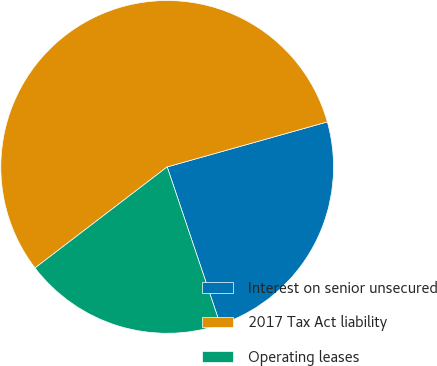Convert chart. <chart><loc_0><loc_0><loc_500><loc_500><pie_chart><fcel>Interest on senior unsecured<fcel>2017 Tax Act liability<fcel>Operating leases<nl><fcel>24.19%<fcel>56.03%<fcel>19.78%<nl></chart> 